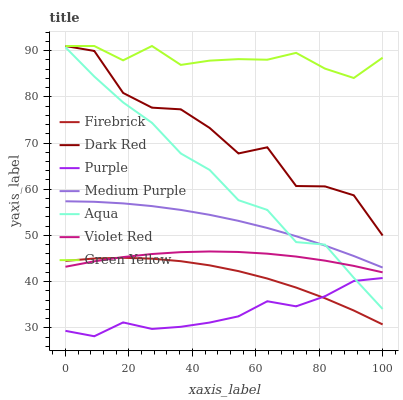Does Purple have the minimum area under the curve?
Answer yes or no. Yes. Does Green Yellow have the maximum area under the curve?
Answer yes or no. Yes. Does Dark Red have the minimum area under the curve?
Answer yes or no. No. Does Dark Red have the maximum area under the curve?
Answer yes or no. No. Is Medium Purple the smoothest?
Answer yes or no. Yes. Is Dark Red the roughest?
Answer yes or no. Yes. Is Purple the smoothest?
Answer yes or no. No. Is Purple the roughest?
Answer yes or no. No. Does Purple have the lowest value?
Answer yes or no. Yes. Does Dark Red have the lowest value?
Answer yes or no. No. Does Green Yellow have the highest value?
Answer yes or no. Yes. Does Purple have the highest value?
Answer yes or no. No. Is Purple less than Violet Red?
Answer yes or no. Yes. Is Green Yellow greater than Violet Red?
Answer yes or no. Yes. Does Dark Red intersect Green Yellow?
Answer yes or no. Yes. Is Dark Red less than Green Yellow?
Answer yes or no. No. Is Dark Red greater than Green Yellow?
Answer yes or no. No. Does Purple intersect Violet Red?
Answer yes or no. No. 